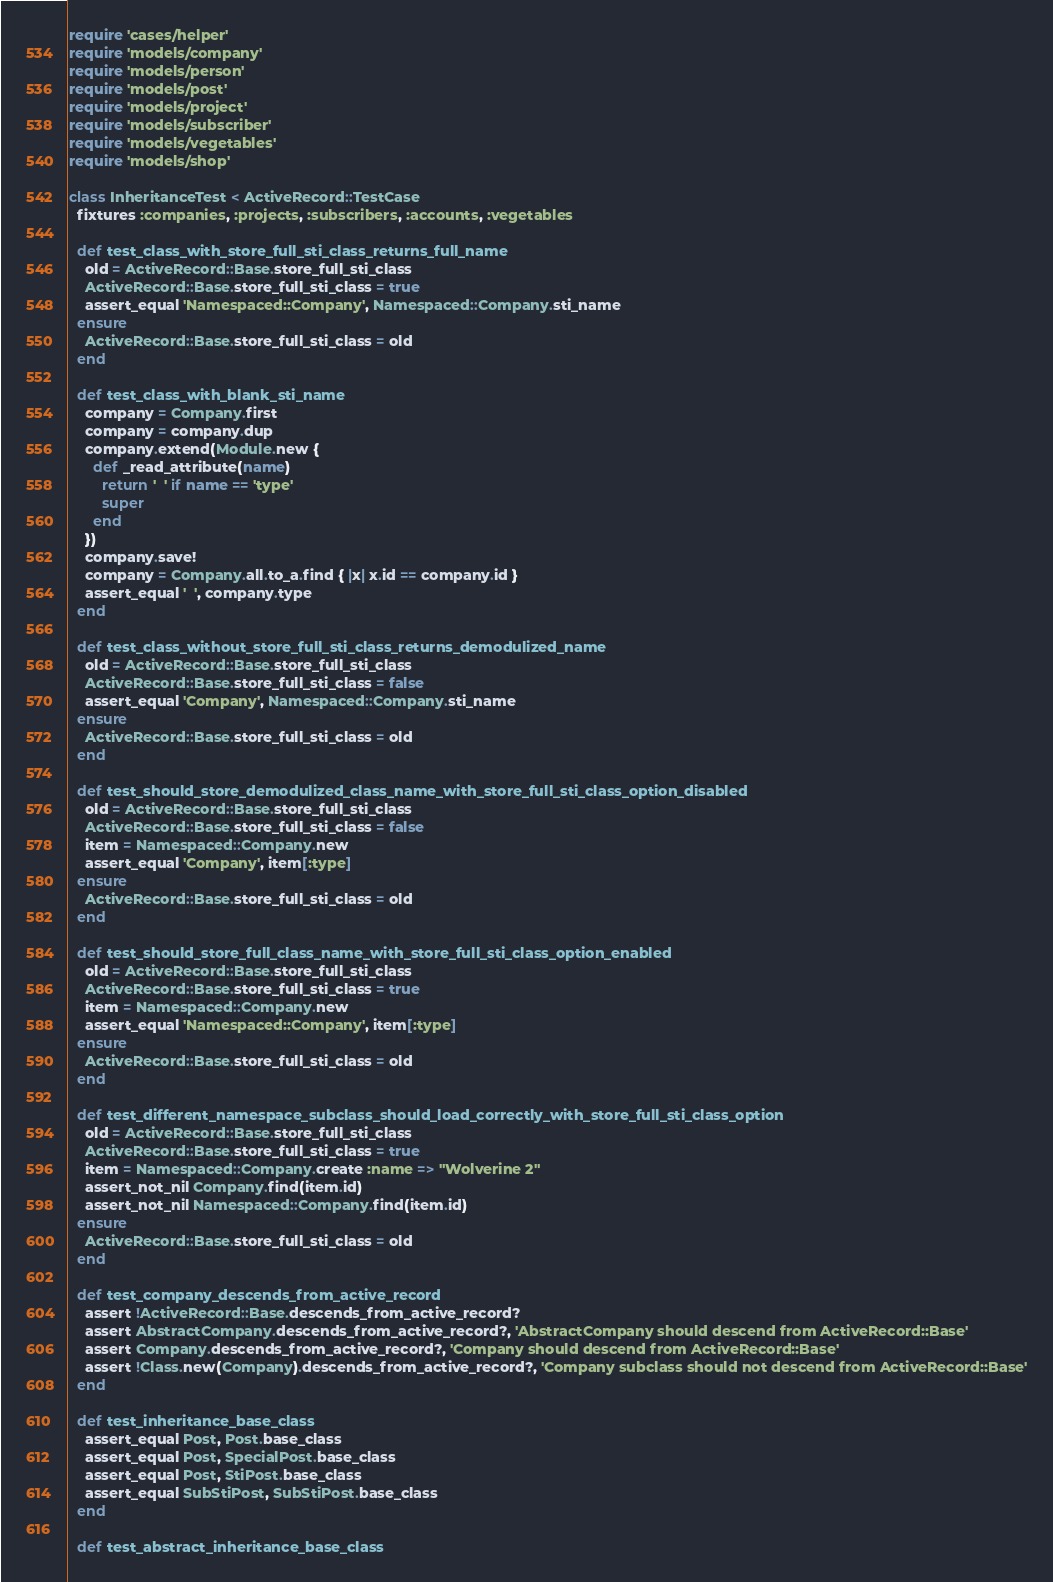<code> <loc_0><loc_0><loc_500><loc_500><_Ruby_>require 'cases/helper'
require 'models/company'
require 'models/person'
require 'models/post'
require 'models/project'
require 'models/subscriber'
require 'models/vegetables'
require 'models/shop'

class InheritanceTest < ActiveRecord::TestCase
  fixtures :companies, :projects, :subscribers, :accounts, :vegetables

  def test_class_with_store_full_sti_class_returns_full_name
    old = ActiveRecord::Base.store_full_sti_class
    ActiveRecord::Base.store_full_sti_class = true
    assert_equal 'Namespaced::Company', Namespaced::Company.sti_name
  ensure
    ActiveRecord::Base.store_full_sti_class = old
  end

  def test_class_with_blank_sti_name
    company = Company.first
    company = company.dup
    company.extend(Module.new {
      def _read_attribute(name)
        return '  ' if name == 'type'
        super
      end
    })
    company.save!
    company = Company.all.to_a.find { |x| x.id == company.id }
    assert_equal '  ', company.type
  end

  def test_class_without_store_full_sti_class_returns_demodulized_name
    old = ActiveRecord::Base.store_full_sti_class
    ActiveRecord::Base.store_full_sti_class = false
    assert_equal 'Company', Namespaced::Company.sti_name
  ensure
    ActiveRecord::Base.store_full_sti_class = old
  end

  def test_should_store_demodulized_class_name_with_store_full_sti_class_option_disabled
    old = ActiveRecord::Base.store_full_sti_class
    ActiveRecord::Base.store_full_sti_class = false
    item = Namespaced::Company.new
    assert_equal 'Company', item[:type]
  ensure
    ActiveRecord::Base.store_full_sti_class = old
  end

  def test_should_store_full_class_name_with_store_full_sti_class_option_enabled
    old = ActiveRecord::Base.store_full_sti_class
    ActiveRecord::Base.store_full_sti_class = true
    item = Namespaced::Company.new
    assert_equal 'Namespaced::Company', item[:type]
  ensure
    ActiveRecord::Base.store_full_sti_class = old
  end

  def test_different_namespace_subclass_should_load_correctly_with_store_full_sti_class_option
    old = ActiveRecord::Base.store_full_sti_class
    ActiveRecord::Base.store_full_sti_class = true
    item = Namespaced::Company.create :name => "Wolverine 2"
    assert_not_nil Company.find(item.id)
    assert_not_nil Namespaced::Company.find(item.id)
  ensure
    ActiveRecord::Base.store_full_sti_class = old
  end

  def test_company_descends_from_active_record
    assert !ActiveRecord::Base.descends_from_active_record?
    assert AbstractCompany.descends_from_active_record?, 'AbstractCompany should descend from ActiveRecord::Base'
    assert Company.descends_from_active_record?, 'Company should descend from ActiveRecord::Base'
    assert !Class.new(Company).descends_from_active_record?, 'Company subclass should not descend from ActiveRecord::Base'
  end

  def test_inheritance_base_class
    assert_equal Post, Post.base_class
    assert_equal Post, SpecialPost.base_class
    assert_equal Post, StiPost.base_class
    assert_equal SubStiPost, SubStiPost.base_class
  end

  def test_abstract_inheritance_base_class</code> 